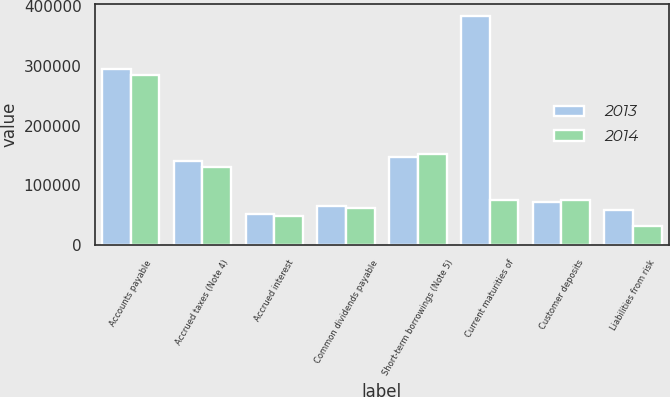<chart> <loc_0><loc_0><loc_500><loc_500><stacked_bar_chart><ecel><fcel>Accounts payable<fcel>Accrued taxes (Note 4)<fcel>Accrued interest<fcel>Common dividends payable<fcel>Short-term borrowings (Note 5)<fcel>Current maturities of<fcel>Customer deposits<fcel>Liabilities from risk<nl><fcel>2013<fcel>295211<fcel>140613<fcel>52603<fcel>65790<fcel>147400<fcel>383570<fcel>72307<fcel>59676<nl><fcel>2014<fcel>284516<fcel>130998<fcel>48351<fcel>62528<fcel>153125<fcel>76101<fcel>76101<fcel>31892<nl></chart> 